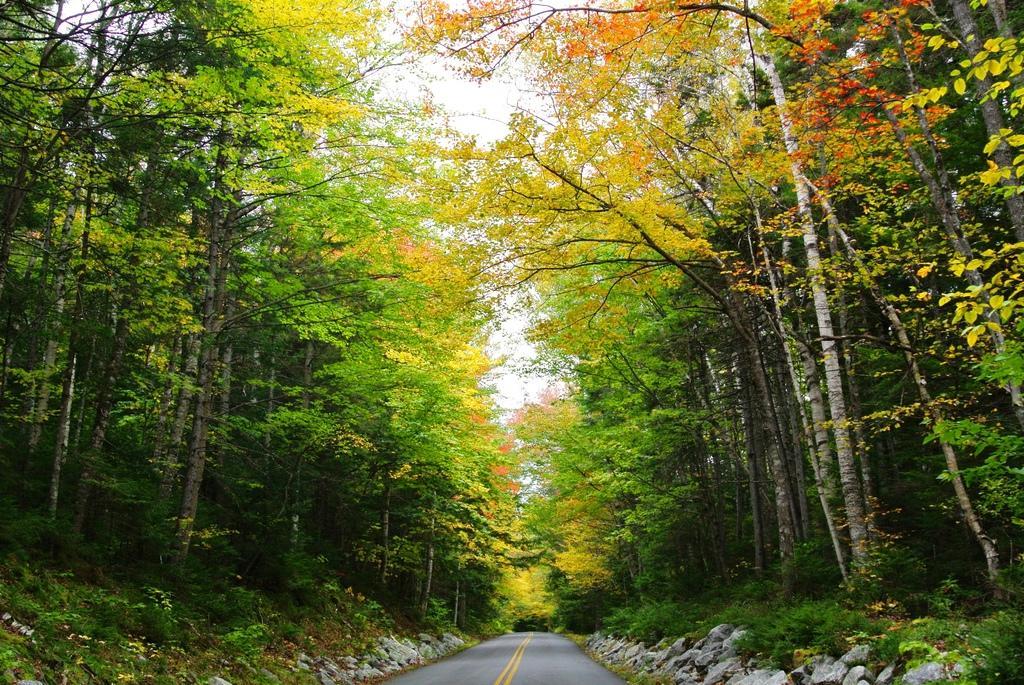Could you give a brief overview of what you see in this image? In this image I can see the road, few rocks and few trees which are green, yellow and orange in color on both sides of the road. In the background I can see the sky. 